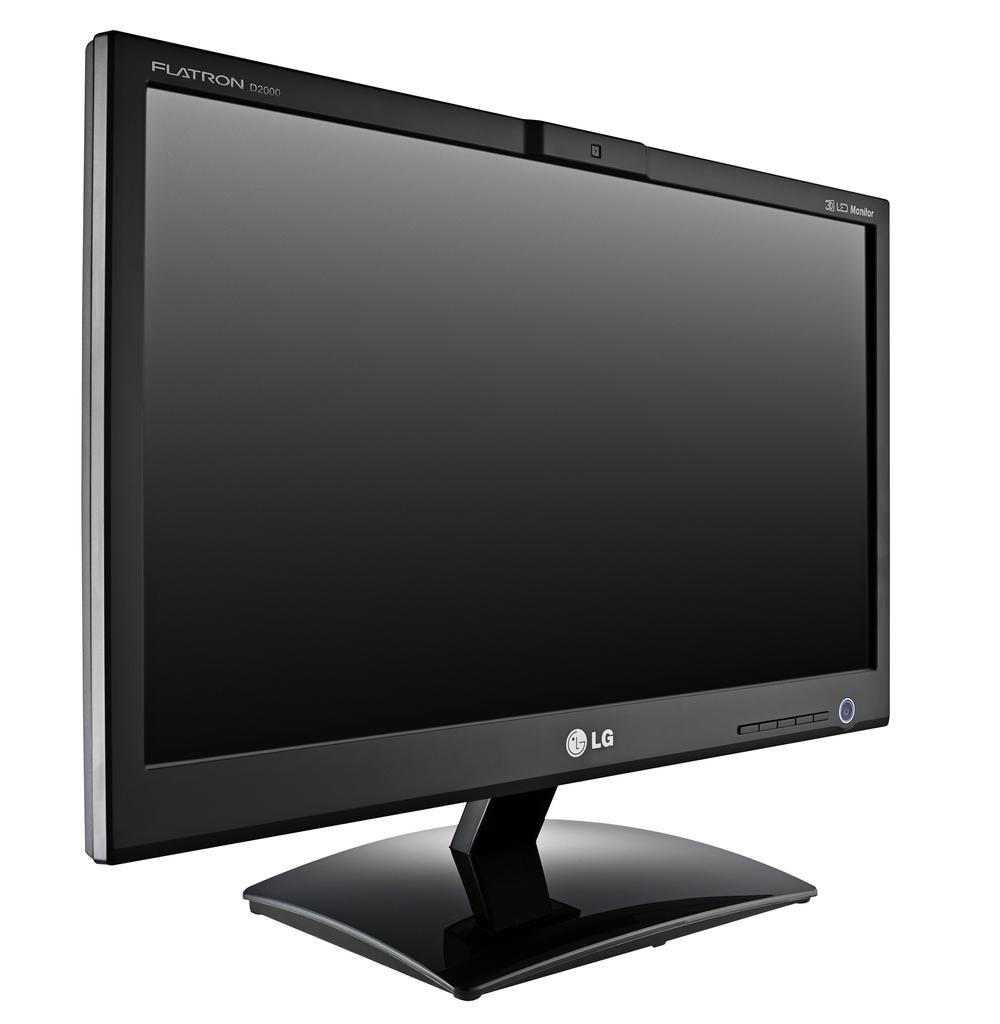What type of television is visible in the image? There is a black color LG television in the image. What type of weather can be seen in the image? There is no weather visible in the image, as it only features a black color LG television. What type of carriage is present in the image? There is no carriage present in the image; it only features a black color LG television. 